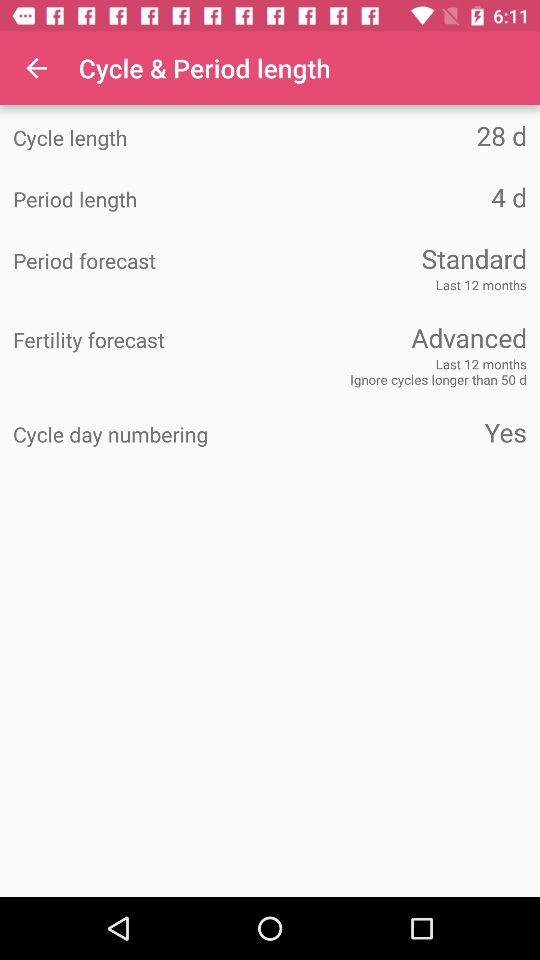Is "Cycle day numbering" a yes or no? "Cycle day numbering" is a yes. 